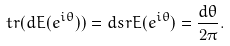Convert formula to latex. <formula><loc_0><loc_0><loc_500><loc_500>t r ( d E ( e ^ { i \theta } ) ) = d s r E ( e ^ { i \theta } ) = \frac { d \theta } { 2 \pi } .</formula> 